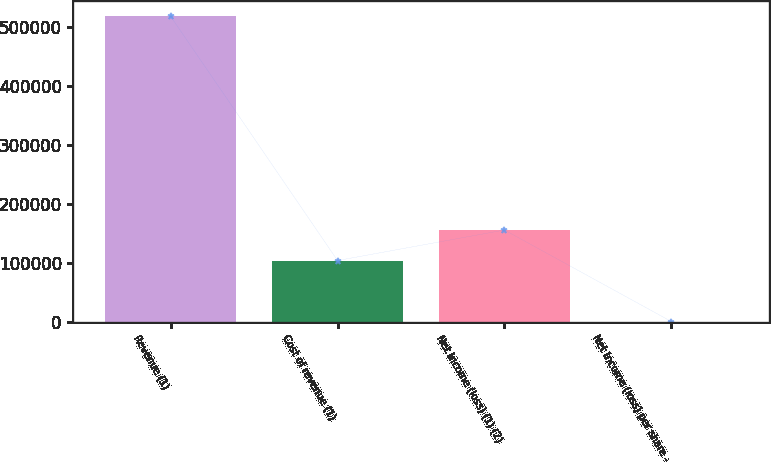<chart> <loc_0><loc_0><loc_500><loc_500><bar_chart><fcel>Revenue (1)<fcel>Cost of revenue (1)<fcel>Net income (loss) (1) (2)<fcel>Net income (loss) per share -<nl><fcel>517313<fcel>103463<fcel>155194<fcel>0.26<nl></chart> 